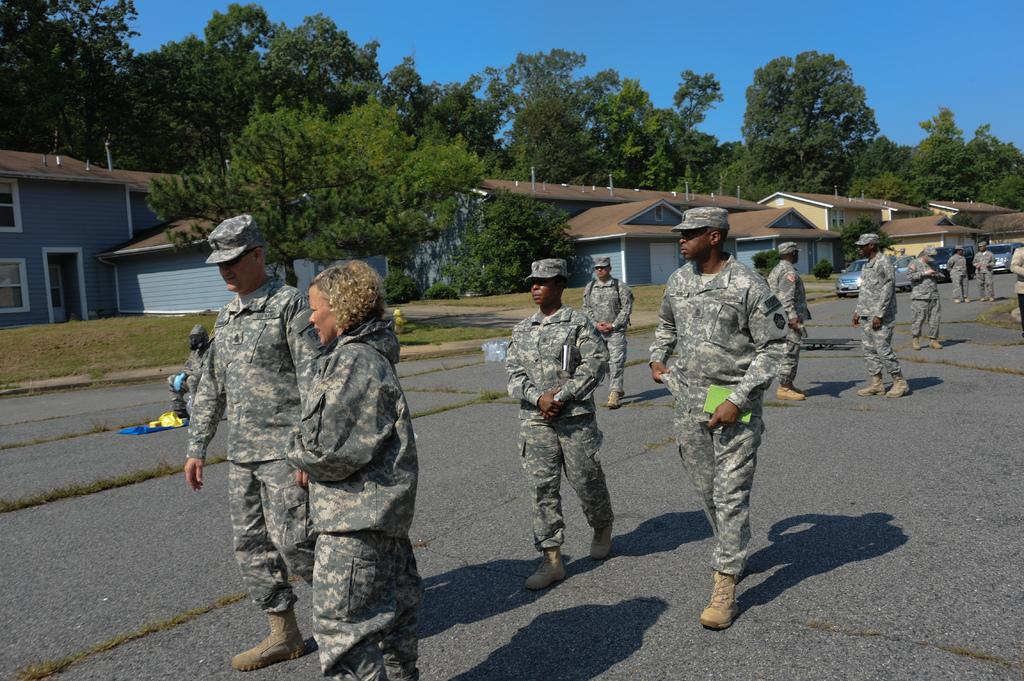What type of people can be seen in the image? There are military people in the image. What type of structures are visible in the image? There are houses in the image. What type of vegetation is present in the image? There are trees in the image. What type of transportation can be seen in the image? There are vehicles in the image. What type of ground cover is present in the image? There is grass in the image. What type of surface is visible in the image? There is a road in the image. What part of the natural environment is visible in the image? The sky is visible in the image. How many dimes are scattered on the grass in the image? There are no dimes present in the image; it features military people, houses, trees, vehicles, grass, a road, and the sky. What type of pen is being used by the military people in the image? There is no pen visible in the image; it only shows military people, houses, trees, vehicles, grass, a road, and the sky. 